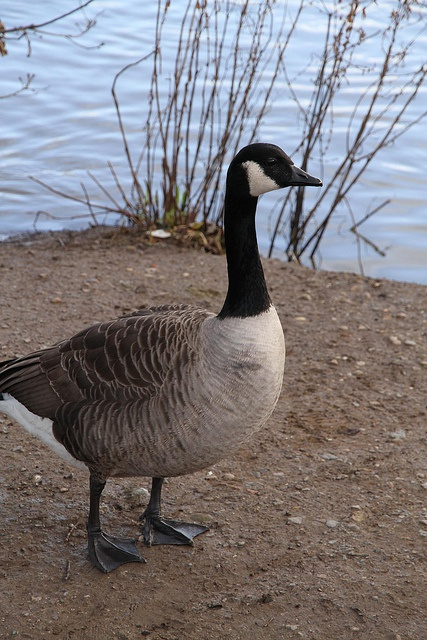Describe the objects in this image and their specific colors. I can see a bird in lightblue, black, gray, and darkgray tones in this image. 